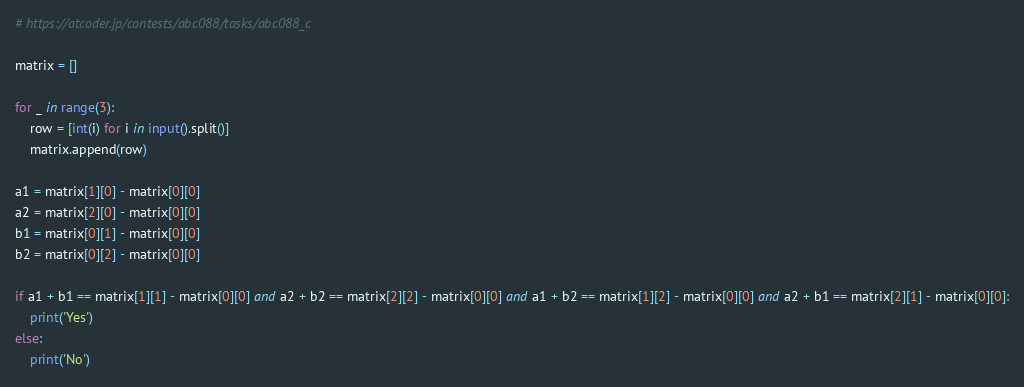Convert code to text. <code><loc_0><loc_0><loc_500><loc_500><_Python_># https://atcoder.jp/contests/abc088/tasks/abc088_c

matrix = []

for _ in range(3):
    row = [int(i) for i in input().split()]
    matrix.append(row)

a1 = matrix[1][0] - matrix[0][0]
a2 = matrix[2][0] - matrix[0][0]
b1 = matrix[0][1] - matrix[0][0]
b2 = matrix[0][2] - matrix[0][0]

if a1 + b1 == matrix[1][1] - matrix[0][0] and a2 + b2 == matrix[2][2] - matrix[0][0] and a1 + b2 == matrix[1][2] - matrix[0][0] and a2 + b1 == matrix[2][1] - matrix[0][0]:
    print('Yes')
else:
    print('No')</code> 